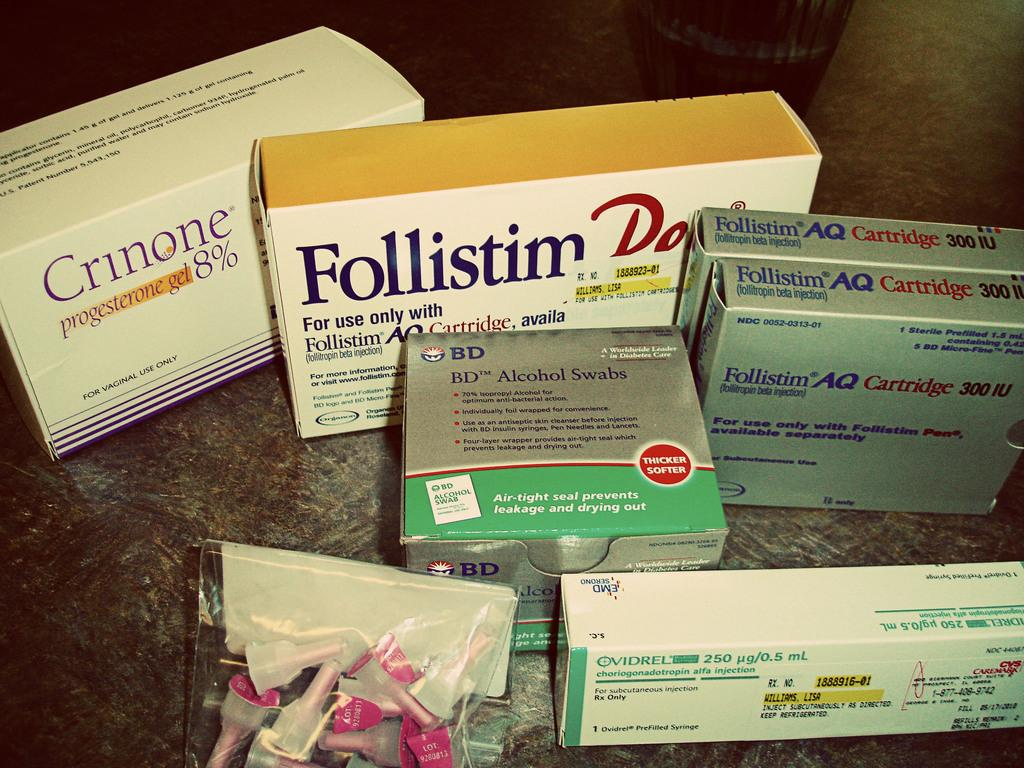<image>
Create a compact narrative representing the image presented. A box in the back has a percentage of 8% on the front. 